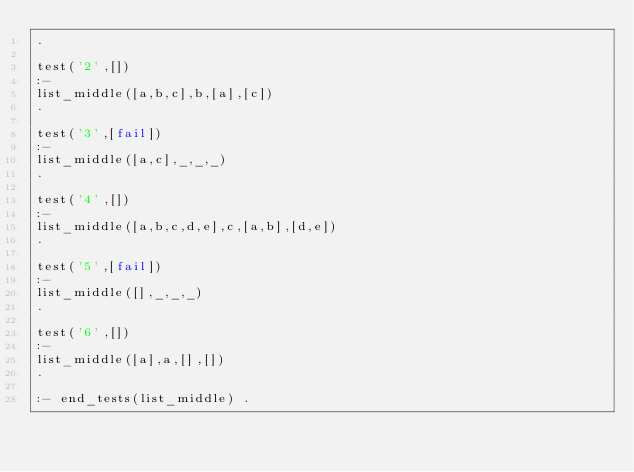Convert code to text. <code><loc_0><loc_0><loc_500><loc_500><_Prolog_>.

test('2',[])
:-
list_middle([a,b,c],b,[a],[c])
.

test('3',[fail])
:-
list_middle([a,c],_,_,_)
.

test('4',[])
:-
list_middle([a,b,c,d,e],c,[a,b],[d,e])
.

test('5',[fail])
:-
list_middle([],_,_,_)
.

test('6',[])
:-
list_middle([a],a,[],[])
.

:- end_tests(list_middle) .
</code> 